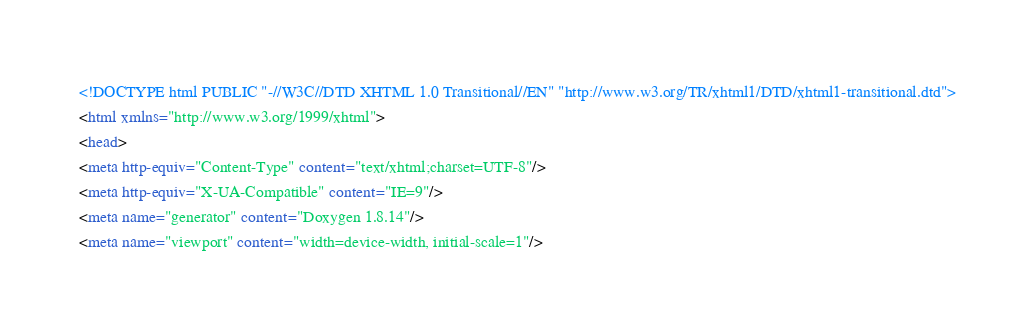Convert code to text. <code><loc_0><loc_0><loc_500><loc_500><_HTML_><!DOCTYPE html PUBLIC "-//W3C//DTD XHTML 1.0 Transitional//EN" "http://www.w3.org/TR/xhtml1/DTD/xhtml1-transitional.dtd">
<html xmlns="http://www.w3.org/1999/xhtml">
<head>
<meta http-equiv="Content-Type" content="text/xhtml;charset=UTF-8"/>
<meta http-equiv="X-UA-Compatible" content="IE=9"/>
<meta name="generator" content="Doxygen 1.8.14"/>
<meta name="viewport" content="width=device-width, initial-scale=1"/></code> 